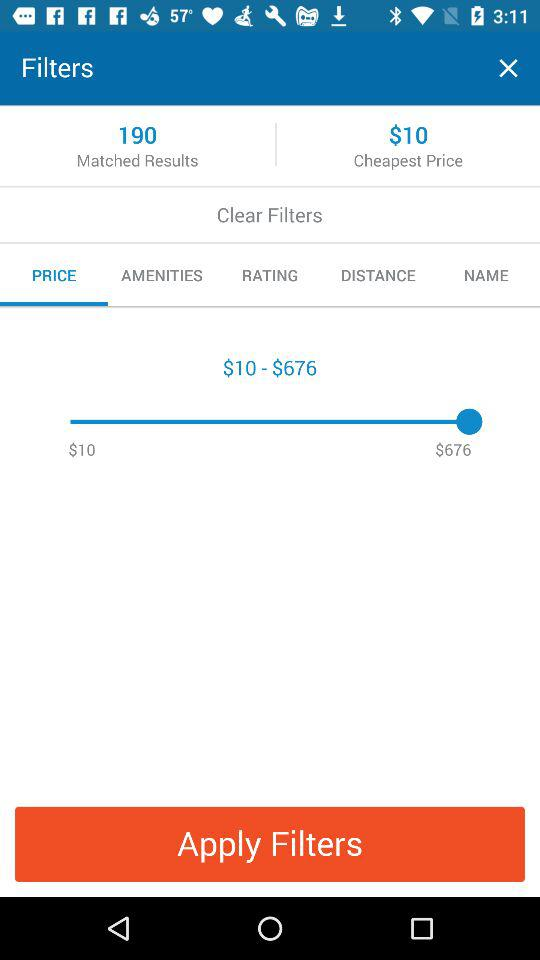Which tab is selected? The selected tab is "PRICE". 